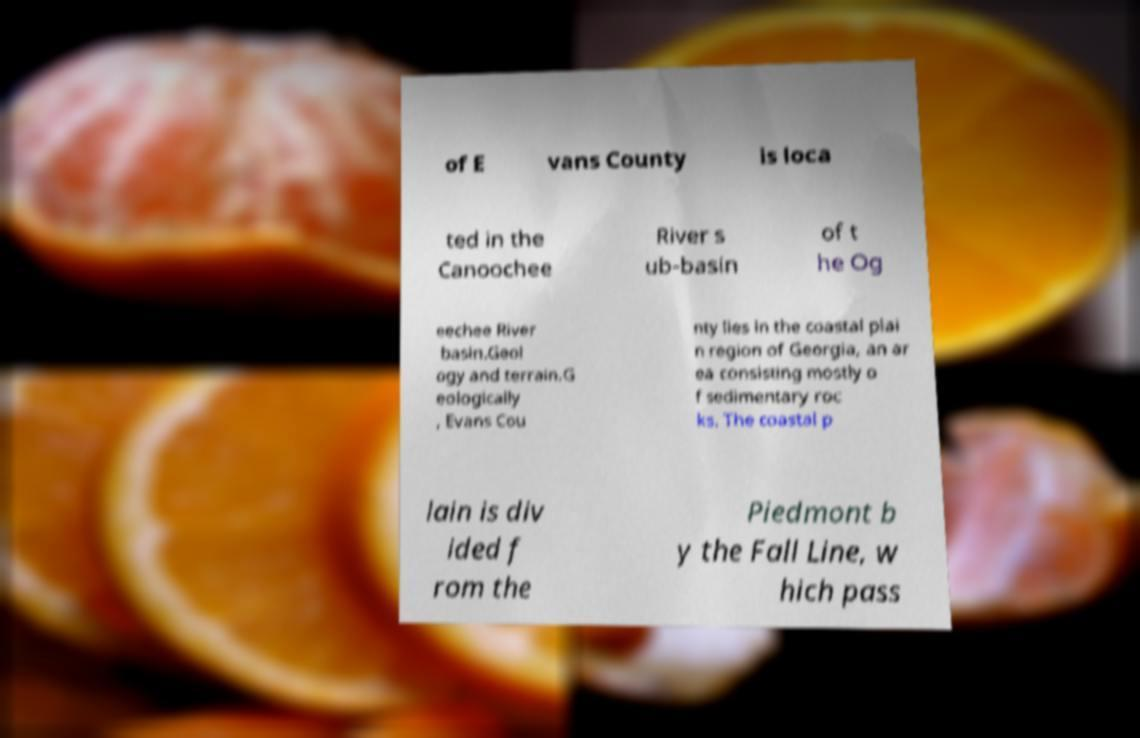What messages or text are displayed in this image? I need them in a readable, typed format. of E vans County is loca ted in the Canoochee River s ub-basin of t he Og eechee River basin.Geol ogy and terrain.G eologically , Evans Cou nty lies in the coastal plai n region of Georgia, an ar ea consisting mostly o f sedimentary roc ks. The coastal p lain is div ided f rom the Piedmont b y the Fall Line, w hich pass 